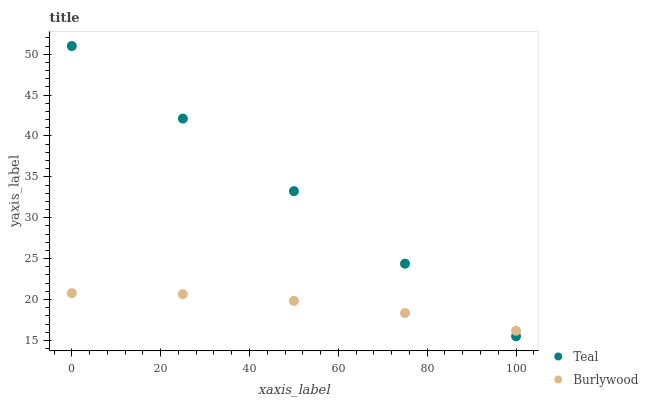Does Burlywood have the minimum area under the curve?
Answer yes or no. Yes. Does Teal have the maximum area under the curve?
Answer yes or no. Yes. Does Teal have the minimum area under the curve?
Answer yes or no. No. Is Teal the smoothest?
Answer yes or no. Yes. Is Burlywood the roughest?
Answer yes or no. Yes. Is Teal the roughest?
Answer yes or no. No. Does Teal have the lowest value?
Answer yes or no. Yes. Does Teal have the highest value?
Answer yes or no. Yes. Does Teal intersect Burlywood?
Answer yes or no. Yes. Is Teal less than Burlywood?
Answer yes or no. No. Is Teal greater than Burlywood?
Answer yes or no. No. 